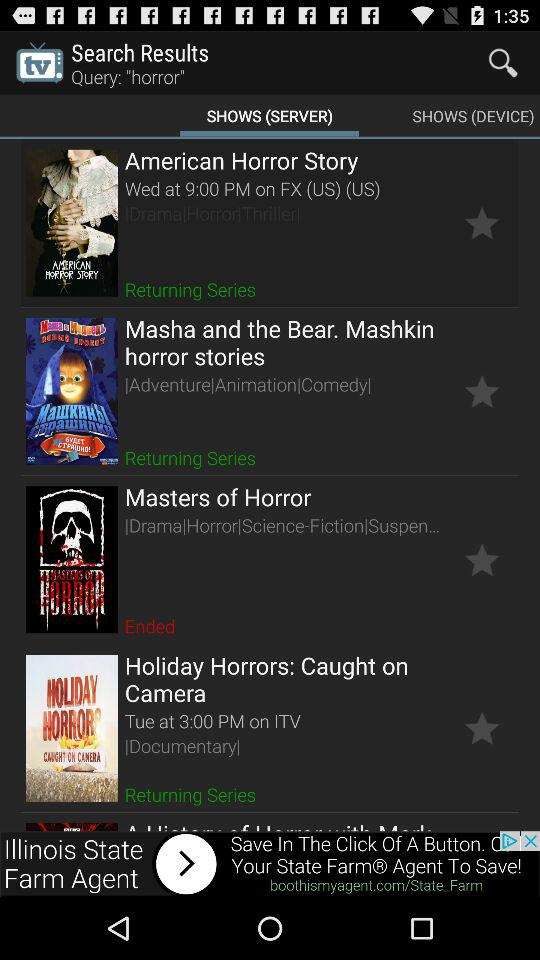What is the show timing of Masha and the bear mashkin horror stories?
When the provided information is insufficient, respond with <no answer>. <no answer> 